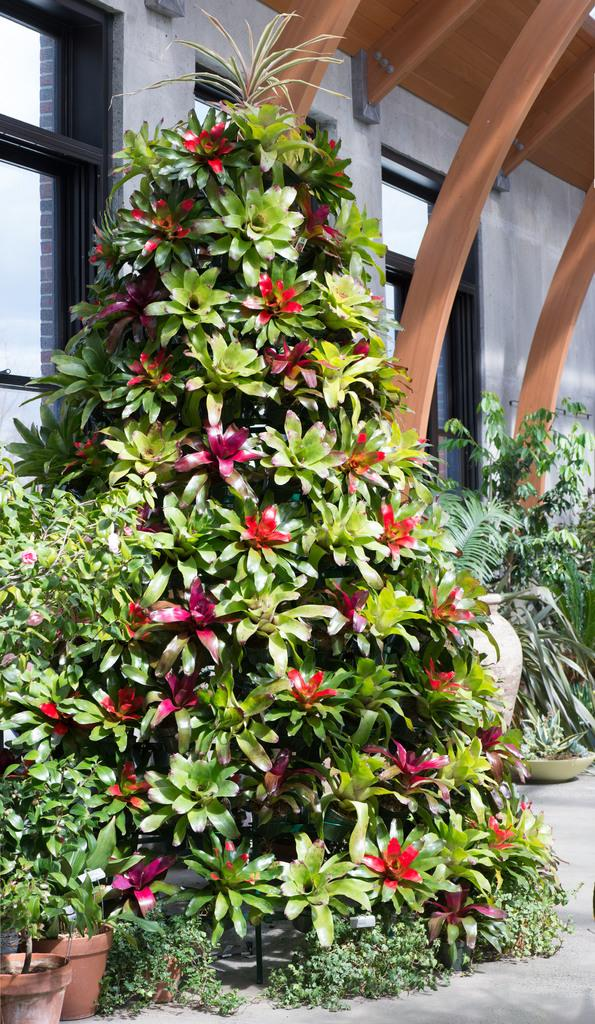What type of living organisms can be seen in the image? Plants can be seen in the image. What are the plants placed in? There are flower pots in the image. What architectural feature is visible in the image? There are glass windows visible in the image. What can be seen in the background of the image? There is a wall visible in the background of the image. What type of railway can be seen in the image? There is no railway present in the image. How many cars are visible in the image? There are no cars present in the image. 